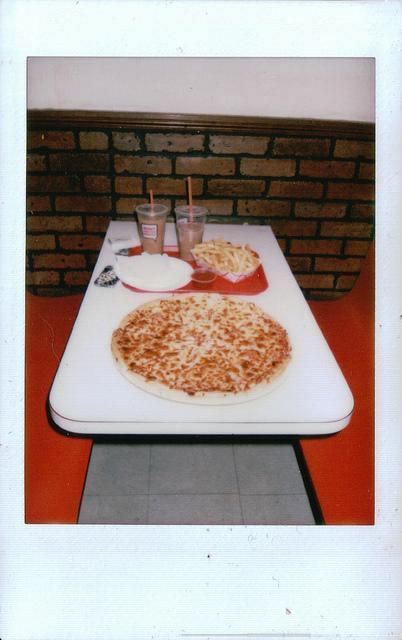How many people is eating this pizza?
Give a very brief answer. 2. How many benches are in the photo?
Give a very brief answer. 2. 